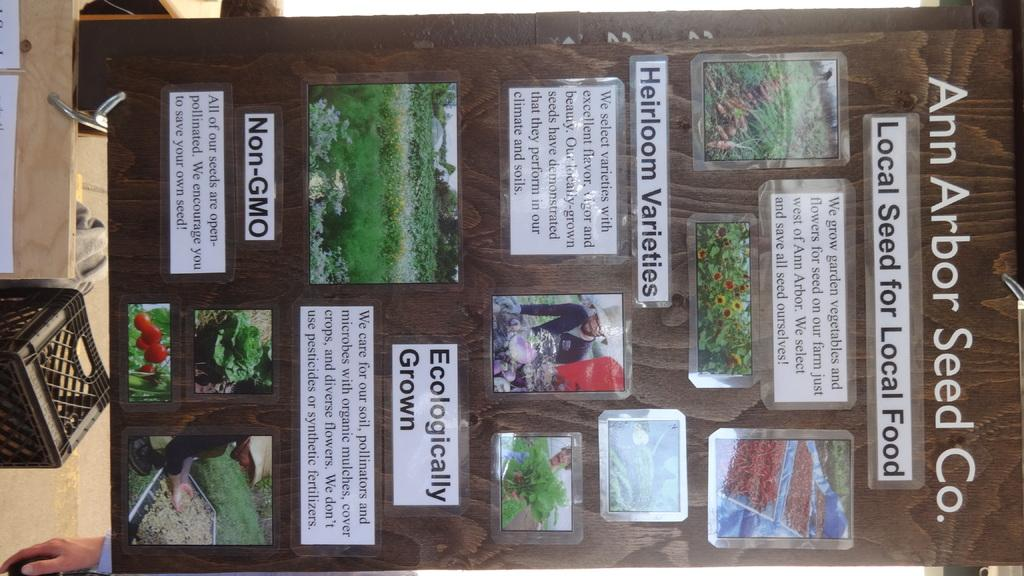<image>
Give a short and clear explanation of the subsequent image. A display of garden pictures on a dark sheet of wood titled Ann Arbor Seed Co. 